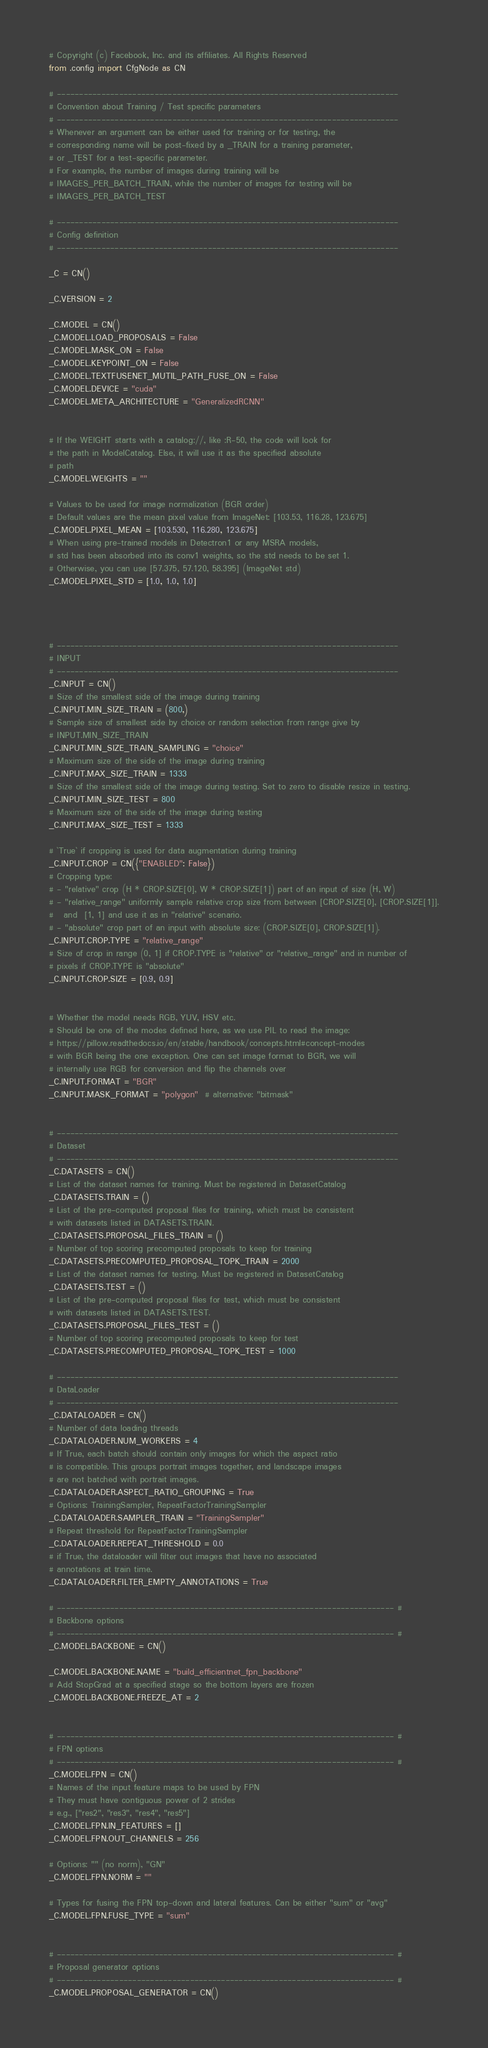<code> <loc_0><loc_0><loc_500><loc_500><_Python_># Copyright (c) Facebook, Inc. and its affiliates. All Rights Reserved
from .config import CfgNode as CN

# -----------------------------------------------------------------------------
# Convention about Training / Test specific parameters
# -----------------------------------------------------------------------------
# Whenever an argument can be either used for training or for testing, the
# corresponding name will be post-fixed by a _TRAIN for a training parameter,
# or _TEST for a test-specific parameter.
# For example, the number of images during training will be
# IMAGES_PER_BATCH_TRAIN, while the number of images for testing will be
# IMAGES_PER_BATCH_TEST

# -----------------------------------------------------------------------------
# Config definition
# -----------------------------------------------------------------------------

_C = CN()

_C.VERSION = 2

_C.MODEL = CN()
_C.MODEL.LOAD_PROPOSALS = False
_C.MODEL.MASK_ON = False
_C.MODEL.KEYPOINT_ON = False
_C.MODEL.TEXTFUSENET_MUTIL_PATH_FUSE_ON = False
_C.MODEL.DEVICE = "cuda"
_C.MODEL.META_ARCHITECTURE = "GeneralizedRCNN"


# If the WEIGHT starts with a catalog://, like :R-50, the code will look for
# the path in ModelCatalog. Else, it will use it as the specified absolute
# path
_C.MODEL.WEIGHTS = ""

# Values to be used for image normalization (BGR order)
# Default values are the mean pixel value from ImageNet: [103.53, 116.28, 123.675]
_C.MODEL.PIXEL_MEAN = [103.530, 116.280, 123.675]
# When using pre-trained models in Detectron1 or any MSRA models,
# std has been absorbed into its conv1 weights, so the std needs to be set 1.
# Otherwise, you can use [57.375, 57.120, 58.395] (ImageNet std)
_C.MODEL.PIXEL_STD = [1.0, 1.0, 1.0]




# -----------------------------------------------------------------------------
# INPUT
# -----------------------------------------------------------------------------
_C.INPUT = CN()
# Size of the smallest side of the image during training
_C.INPUT.MIN_SIZE_TRAIN = (800,)
# Sample size of smallest side by choice or random selection from range give by
# INPUT.MIN_SIZE_TRAIN
_C.INPUT.MIN_SIZE_TRAIN_SAMPLING = "choice"
# Maximum size of the side of the image during training
_C.INPUT.MAX_SIZE_TRAIN = 1333
# Size of the smallest side of the image during testing. Set to zero to disable resize in testing.
_C.INPUT.MIN_SIZE_TEST = 800
# Maximum size of the side of the image during testing
_C.INPUT.MAX_SIZE_TEST = 1333

# `True` if cropping is used for data augmentation during training
_C.INPUT.CROP = CN({"ENABLED": False})
# Cropping type:
# - "relative" crop (H * CROP.SIZE[0], W * CROP.SIZE[1]) part of an input of size (H, W)
# - "relative_range" uniformly sample relative crop size from between [CROP.SIZE[0], [CROP.SIZE[1]].
#   and  [1, 1] and use it as in "relative" scenario.
# - "absolute" crop part of an input with absolute size: (CROP.SIZE[0], CROP.SIZE[1]).
_C.INPUT.CROP.TYPE = "relative_range"
# Size of crop in range (0, 1] if CROP.TYPE is "relative" or "relative_range" and in number of
# pixels if CROP.TYPE is "absolute"
_C.INPUT.CROP.SIZE = [0.9, 0.9]


# Whether the model needs RGB, YUV, HSV etc.
# Should be one of the modes defined here, as we use PIL to read the image:
# https://pillow.readthedocs.io/en/stable/handbook/concepts.html#concept-modes
# with BGR being the one exception. One can set image format to BGR, we will
# internally use RGB for conversion and flip the channels over
_C.INPUT.FORMAT = "BGR"
_C.INPUT.MASK_FORMAT = "polygon"  # alternative: "bitmask"


# -----------------------------------------------------------------------------
# Dataset
# -----------------------------------------------------------------------------
_C.DATASETS = CN()
# List of the dataset names for training. Must be registered in DatasetCatalog
_C.DATASETS.TRAIN = ()
# List of the pre-computed proposal files for training, which must be consistent
# with datasets listed in DATASETS.TRAIN.
_C.DATASETS.PROPOSAL_FILES_TRAIN = ()
# Number of top scoring precomputed proposals to keep for training
_C.DATASETS.PRECOMPUTED_PROPOSAL_TOPK_TRAIN = 2000
# List of the dataset names for testing. Must be registered in DatasetCatalog
_C.DATASETS.TEST = ()
# List of the pre-computed proposal files for test, which must be consistent
# with datasets listed in DATASETS.TEST.
_C.DATASETS.PROPOSAL_FILES_TEST = ()
# Number of top scoring precomputed proposals to keep for test
_C.DATASETS.PRECOMPUTED_PROPOSAL_TOPK_TEST = 1000

# -----------------------------------------------------------------------------
# DataLoader
# -----------------------------------------------------------------------------
_C.DATALOADER = CN()
# Number of data loading threads
_C.DATALOADER.NUM_WORKERS = 4
# If True, each batch should contain only images for which the aspect ratio
# is compatible. This groups portrait images together, and landscape images
# are not batched with portrait images.
_C.DATALOADER.ASPECT_RATIO_GROUPING = True
# Options: TrainingSampler, RepeatFactorTrainingSampler
_C.DATALOADER.SAMPLER_TRAIN = "TrainingSampler"
# Repeat threshold for RepeatFactorTrainingSampler
_C.DATALOADER.REPEAT_THRESHOLD = 0.0
# if True, the dataloader will filter out images that have no associated
# annotations at train time.
_C.DATALOADER.FILTER_EMPTY_ANNOTATIONS = True

# ---------------------------------------------------------------------------- #
# Backbone options
# ---------------------------------------------------------------------------- #
_C.MODEL.BACKBONE = CN()

_C.MODEL.BACKBONE.NAME = "build_efficientnet_fpn_backbone"
# Add StopGrad at a specified stage so the bottom layers are frozen
_C.MODEL.BACKBONE.FREEZE_AT = 2


# ---------------------------------------------------------------------------- #
# FPN options
# ---------------------------------------------------------------------------- #
_C.MODEL.FPN = CN()
# Names of the input feature maps to be used by FPN
# They must have contiguous power of 2 strides
# e.g., ["res2", "res3", "res4", "res5"]
_C.MODEL.FPN.IN_FEATURES = []
_C.MODEL.FPN.OUT_CHANNELS = 256

# Options: "" (no norm), "GN"
_C.MODEL.FPN.NORM = ""

# Types for fusing the FPN top-down and lateral features. Can be either "sum" or "avg"
_C.MODEL.FPN.FUSE_TYPE = "sum"


# ---------------------------------------------------------------------------- #
# Proposal generator options
# ---------------------------------------------------------------------------- #
_C.MODEL.PROPOSAL_GENERATOR = CN()</code> 